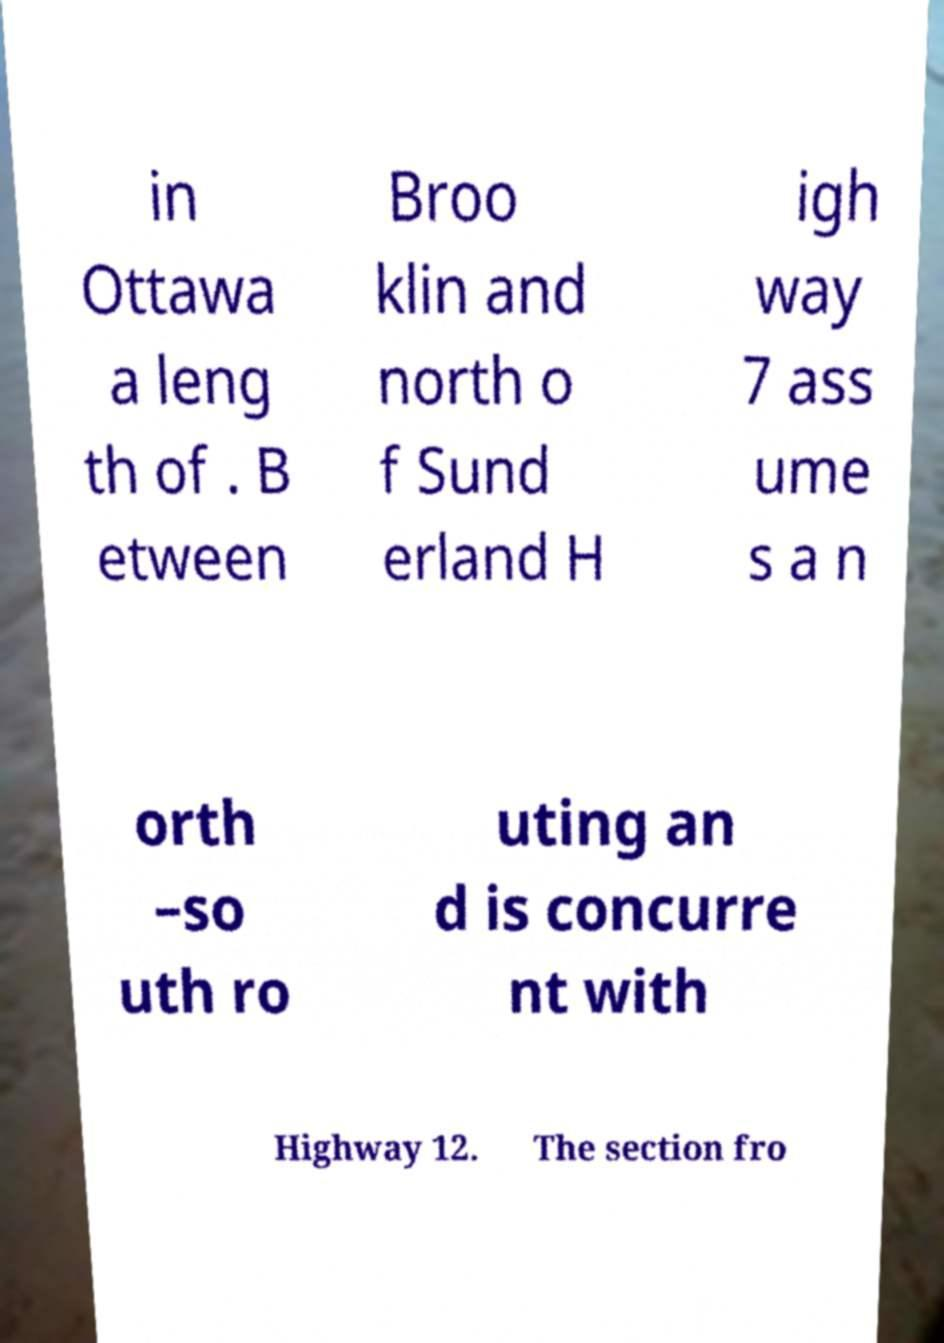Can you read and provide the text displayed in the image?This photo seems to have some interesting text. Can you extract and type it out for me? in Ottawa a leng th of . B etween Broo klin and north o f Sund erland H igh way 7 ass ume s a n orth –so uth ro uting an d is concurre nt with Highway 12. The section fro 